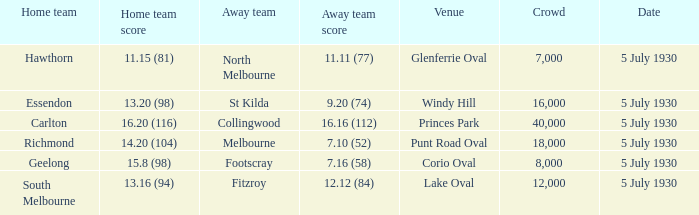Who is the home team when melbourne is the away team? 14.20 (104). 